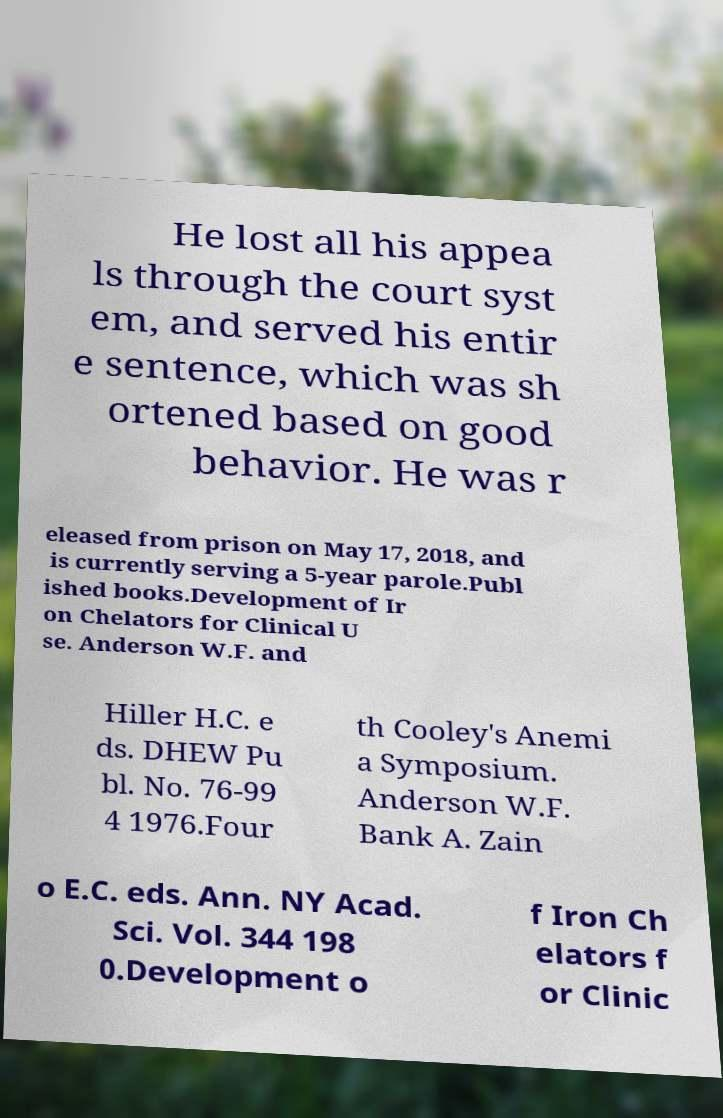Please read and relay the text visible in this image. What does it say? He lost all his appea ls through the court syst em, and served his entir e sentence, which was sh ortened based on good behavior. He was r eleased from prison on May 17, 2018, and is currently serving a 5-year parole.Publ ished books.Development of Ir on Chelators for Clinical U se. Anderson W.F. and Hiller H.C. e ds. DHEW Pu bl. No. 76-99 4 1976.Four th Cooley's Anemi a Symposium. Anderson W.F. Bank A. Zain o E.C. eds. Ann. NY Acad. Sci. Vol. 344 198 0.Development o f Iron Ch elators f or Clinic 